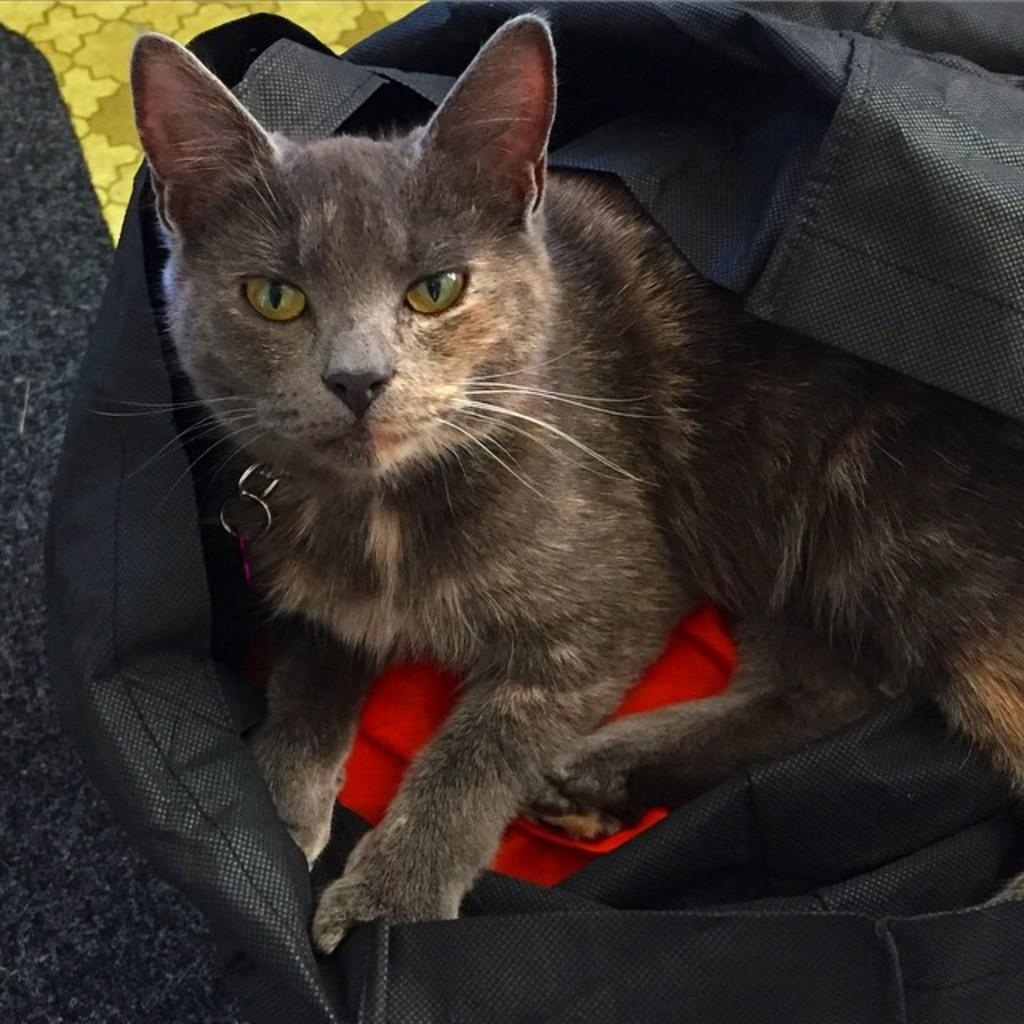What type of animal is in the bag in the image? There is a cat in the bag in the image. What can be seen on the floor in the image? There appears to be a mat on the floor in the image. What type of brass instrument is being played by the cat in the image? There is no brass instrument present in the image, and the cat is not playing any instrument. 